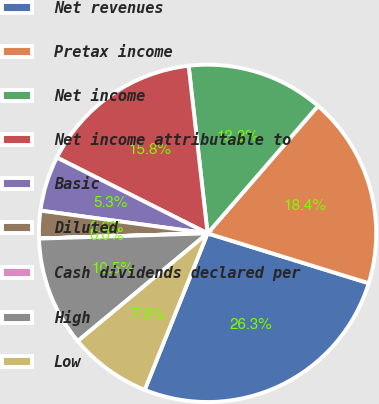Convert chart to OTSL. <chart><loc_0><loc_0><loc_500><loc_500><pie_chart><fcel>Net revenues<fcel>Pretax income<fcel>Net income<fcel>Net income attributable to<fcel>Basic<fcel>Diluted<fcel>Cash dividends declared per<fcel>High<fcel>Low<nl><fcel>26.31%<fcel>18.42%<fcel>13.16%<fcel>15.79%<fcel>5.27%<fcel>2.64%<fcel>0.01%<fcel>10.53%<fcel>7.9%<nl></chart> 